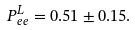<formula> <loc_0><loc_0><loc_500><loc_500>P _ { e e } ^ { L } = 0 . 5 1 \pm 0 . 1 5 .</formula> 